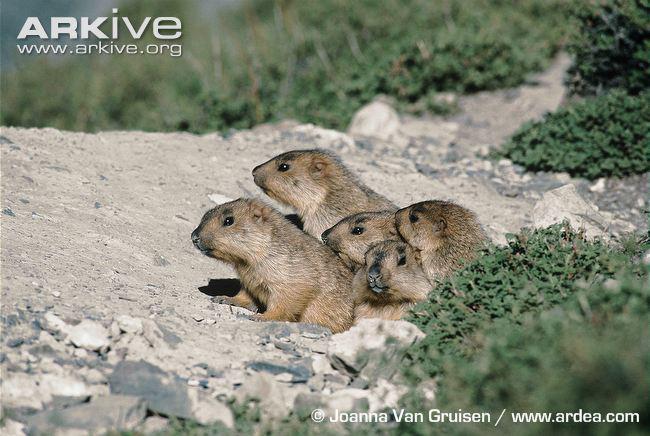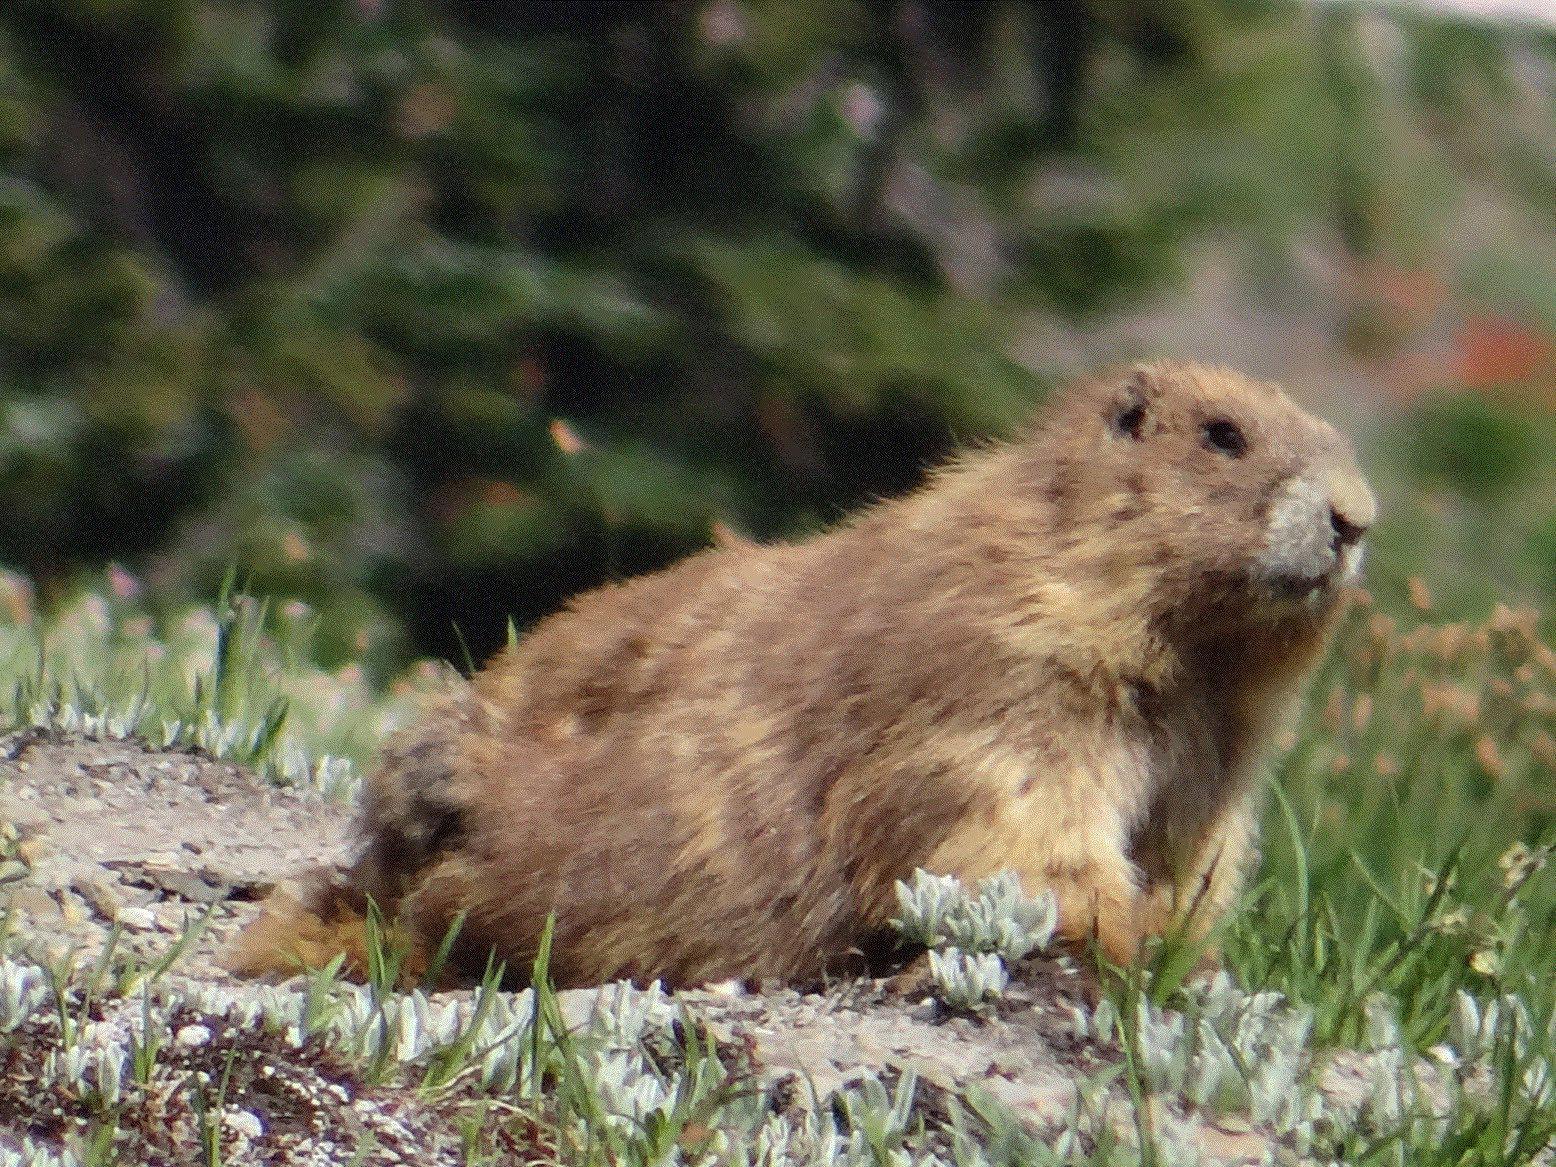The first image is the image on the left, the second image is the image on the right. Assess this claim about the two images: "There are more animals in the image on the left.". Correct or not? Answer yes or no. Yes. The first image is the image on the left, the second image is the image on the right. For the images displayed, is the sentence "The combined images include at least two marmots with their heads raised and gazing leftward." factually correct? Answer yes or no. Yes. 